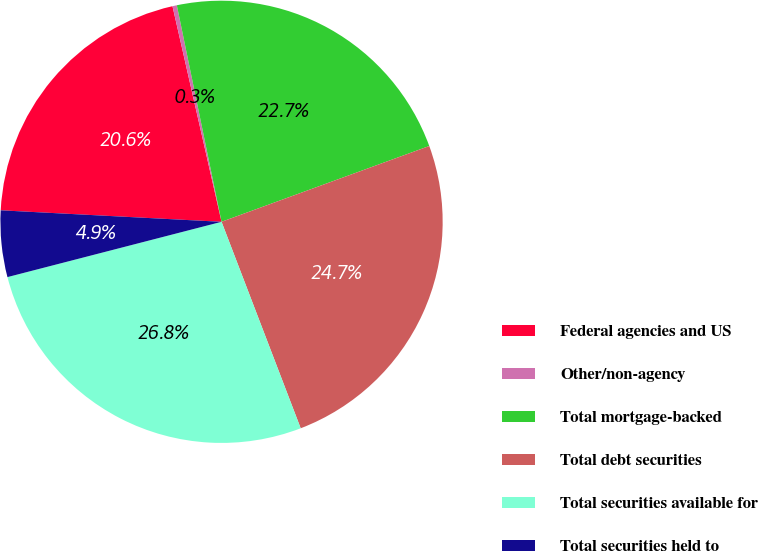Convert chart. <chart><loc_0><loc_0><loc_500><loc_500><pie_chart><fcel>Federal agencies and US<fcel>Other/non-agency<fcel>Total mortgage-backed<fcel>Total debt securities<fcel>Total securities available for<fcel>Total securities held to<nl><fcel>20.61%<fcel>0.32%<fcel>22.67%<fcel>24.74%<fcel>26.8%<fcel>4.85%<nl></chart> 